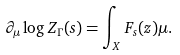Convert formula to latex. <formula><loc_0><loc_0><loc_500><loc_500>\partial _ { \mu } \log Z _ { \Gamma } ( s ) = \int _ { X } F _ { s } ( z ) \mu .</formula> 